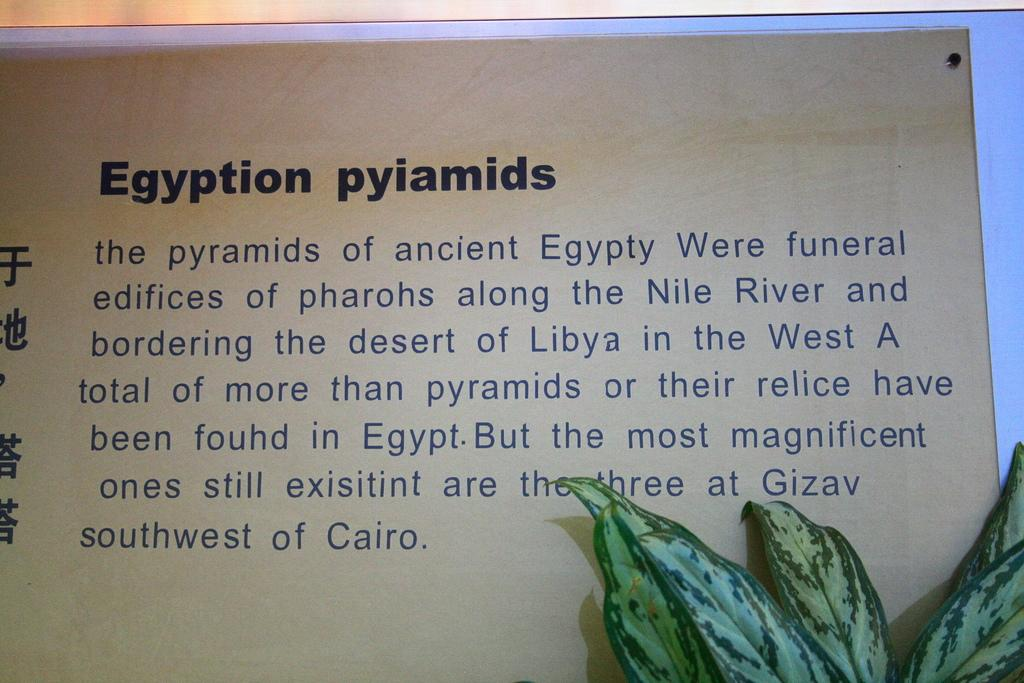Provide a one-sentence caption for the provided image. A text that explains about Egyption Pyiamids and where to find them. 